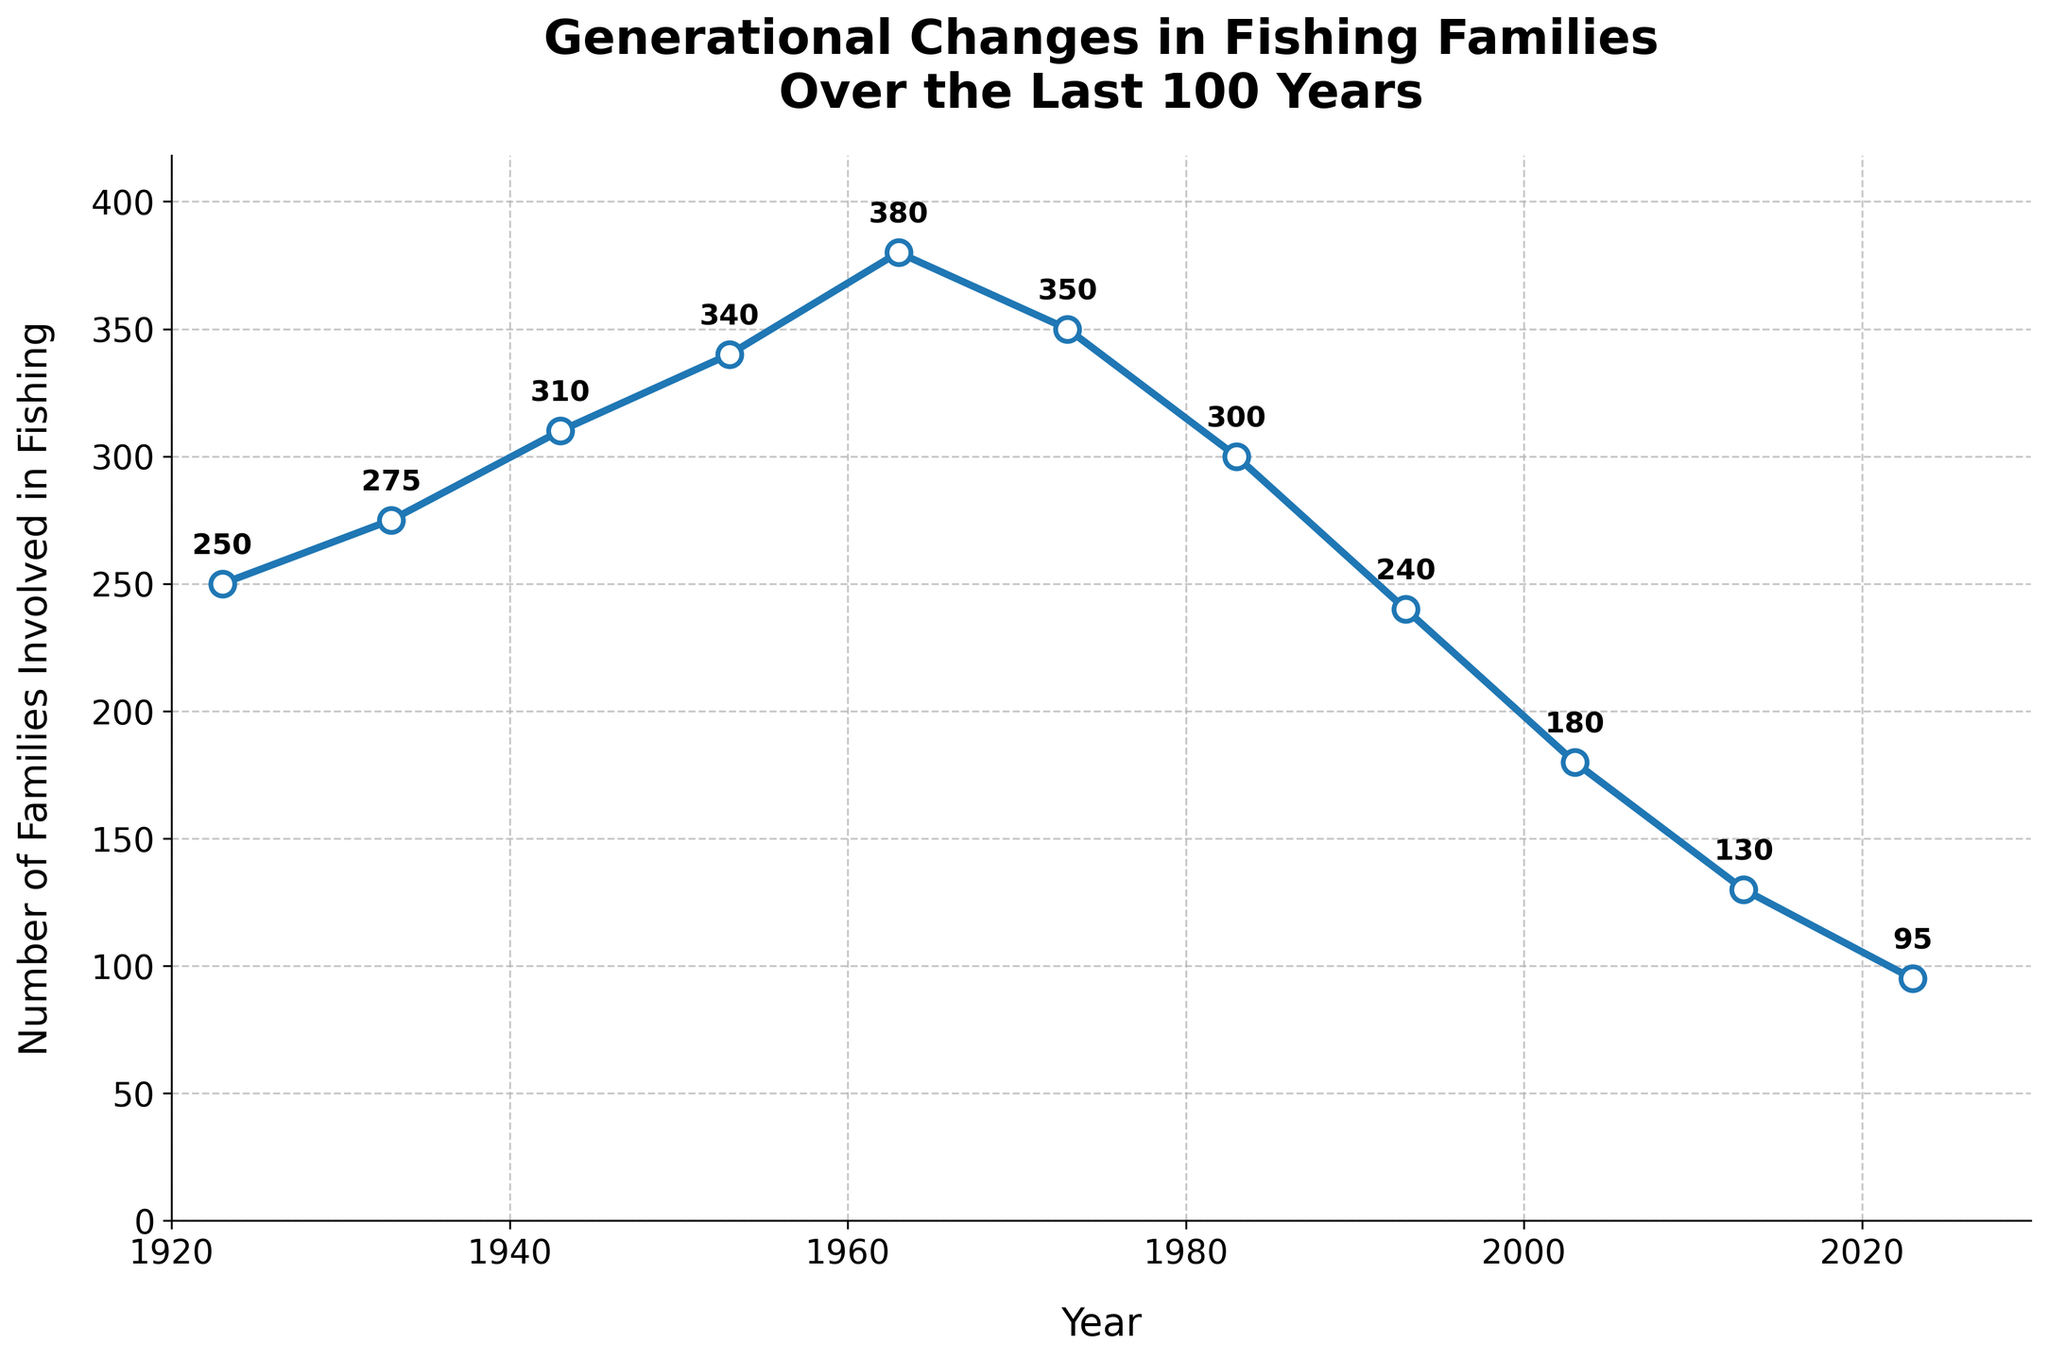What is the number of families involved in fishing in 1963? Look at the point on the line for the year 1963 and read the value
Answer: 380 Between which two decades is the largest decrease in the number of families involved in fishing? Compare the differences in families involved between each pair of consecutive decades and identify the largest decrease
Answer: Between 2003 and 2013 By how much did the number of families involved in fishing decrease from 1973 to 1983? Subtract the number of families in 1983 from the number of families in 1973
Answer: 350 - 300 = 50 What is the average number of families involved in fishing between 2003 and 2023? Sum the values for 2003, 2013, and 2023, then divide by 3
Answer: (180 + 130 + 95) / 3 = 135 Compare the number of families involved in fishing in 1953 and 1983. Which year had more families? Look at the values for the years 1953 and 1983 and compare them
Answer: 1953 had more families What is the highest recorded number of families involved in fishing over the 100 years? Identify the highest number in the dataset
Answer: 380 How has the number of families involved in fishing changed from 1923 to 2023? Look at the values for 1923 and 2023 and calculate the difference
Answer: 1923: 250, 2023: 95, so the decrease is 250 - 95 = 155 Identify the decade with the smallest number of families involved in fishing. Compare the values for each decade and find the smallest
Answer: 2020s (2023: 95) Calculate the percentage decrease in the number of families involved in fishing from 1983 to 2023. Use the formula: ((value_1983 - value_2023) / value_1983) * 100
Answer: ((300 - 95) / 300) * 100 ≈ 68.33% What is the trend observed in the number of families involved in fishing from 1943 to 1953? Look at the points for 1943 and 1953 to determine if the line goes up or down
Answer: Increasing 